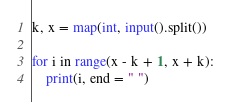<code> <loc_0><loc_0><loc_500><loc_500><_Python_>k, x = map(int, input().split())

for i in range(x - k + 1, x + k):
    print(i, end = " ")</code> 